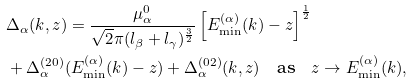<formula> <loc_0><loc_0><loc_500><loc_500>& \Delta _ { \alpha } ( k , z ) = \frac { \mu _ { \alpha } ^ { 0 } } { \sqrt { 2 } \pi ( l _ { \beta } + l _ { \gamma } ) ^ { \frac { 3 } { 2 } } } \left [ E ^ { ( \alpha ) } _ { \min } ( k ) - z \right ] ^ { \frac { 1 } { 2 } } \\ & + \Delta ^ { ( 2 0 ) } _ { \alpha } ( E ^ { ( \alpha ) } _ { \min } ( k ) - z ) + \Delta ^ { ( 0 2 ) } _ { \alpha } ( k , z ) \quad \text {as} \quad z \to E ^ { ( \alpha ) } _ { \min } ( k ) ,</formula> 